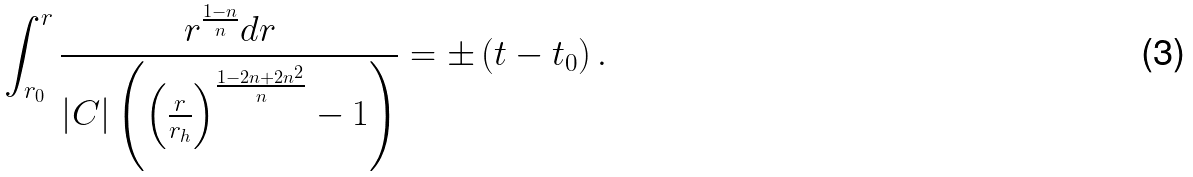<formula> <loc_0><loc_0><loc_500><loc_500>\int _ { r _ { 0 } } ^ { r } \frac { r ^ { \frac { 1 - n } { n } } d r } { \left | C \right | \left ( \left ( \frac { r } { r _ { h } } \right ) ^ { \frac { 1 - 2 n + 2 n ^ { 2 } } { n } } - 1 \right ) } = \pm \left ( t - t _ { 0 } \right ) .</formula> 